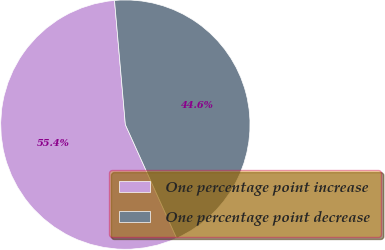<chart> <loc_0><loc_0><loc_500><loc_500><pie_chart><fcel>One percentage point increase<fcel>One percentage point decrease<nl><fcel>55.36%<fcel>44.64%<nl></chart> 